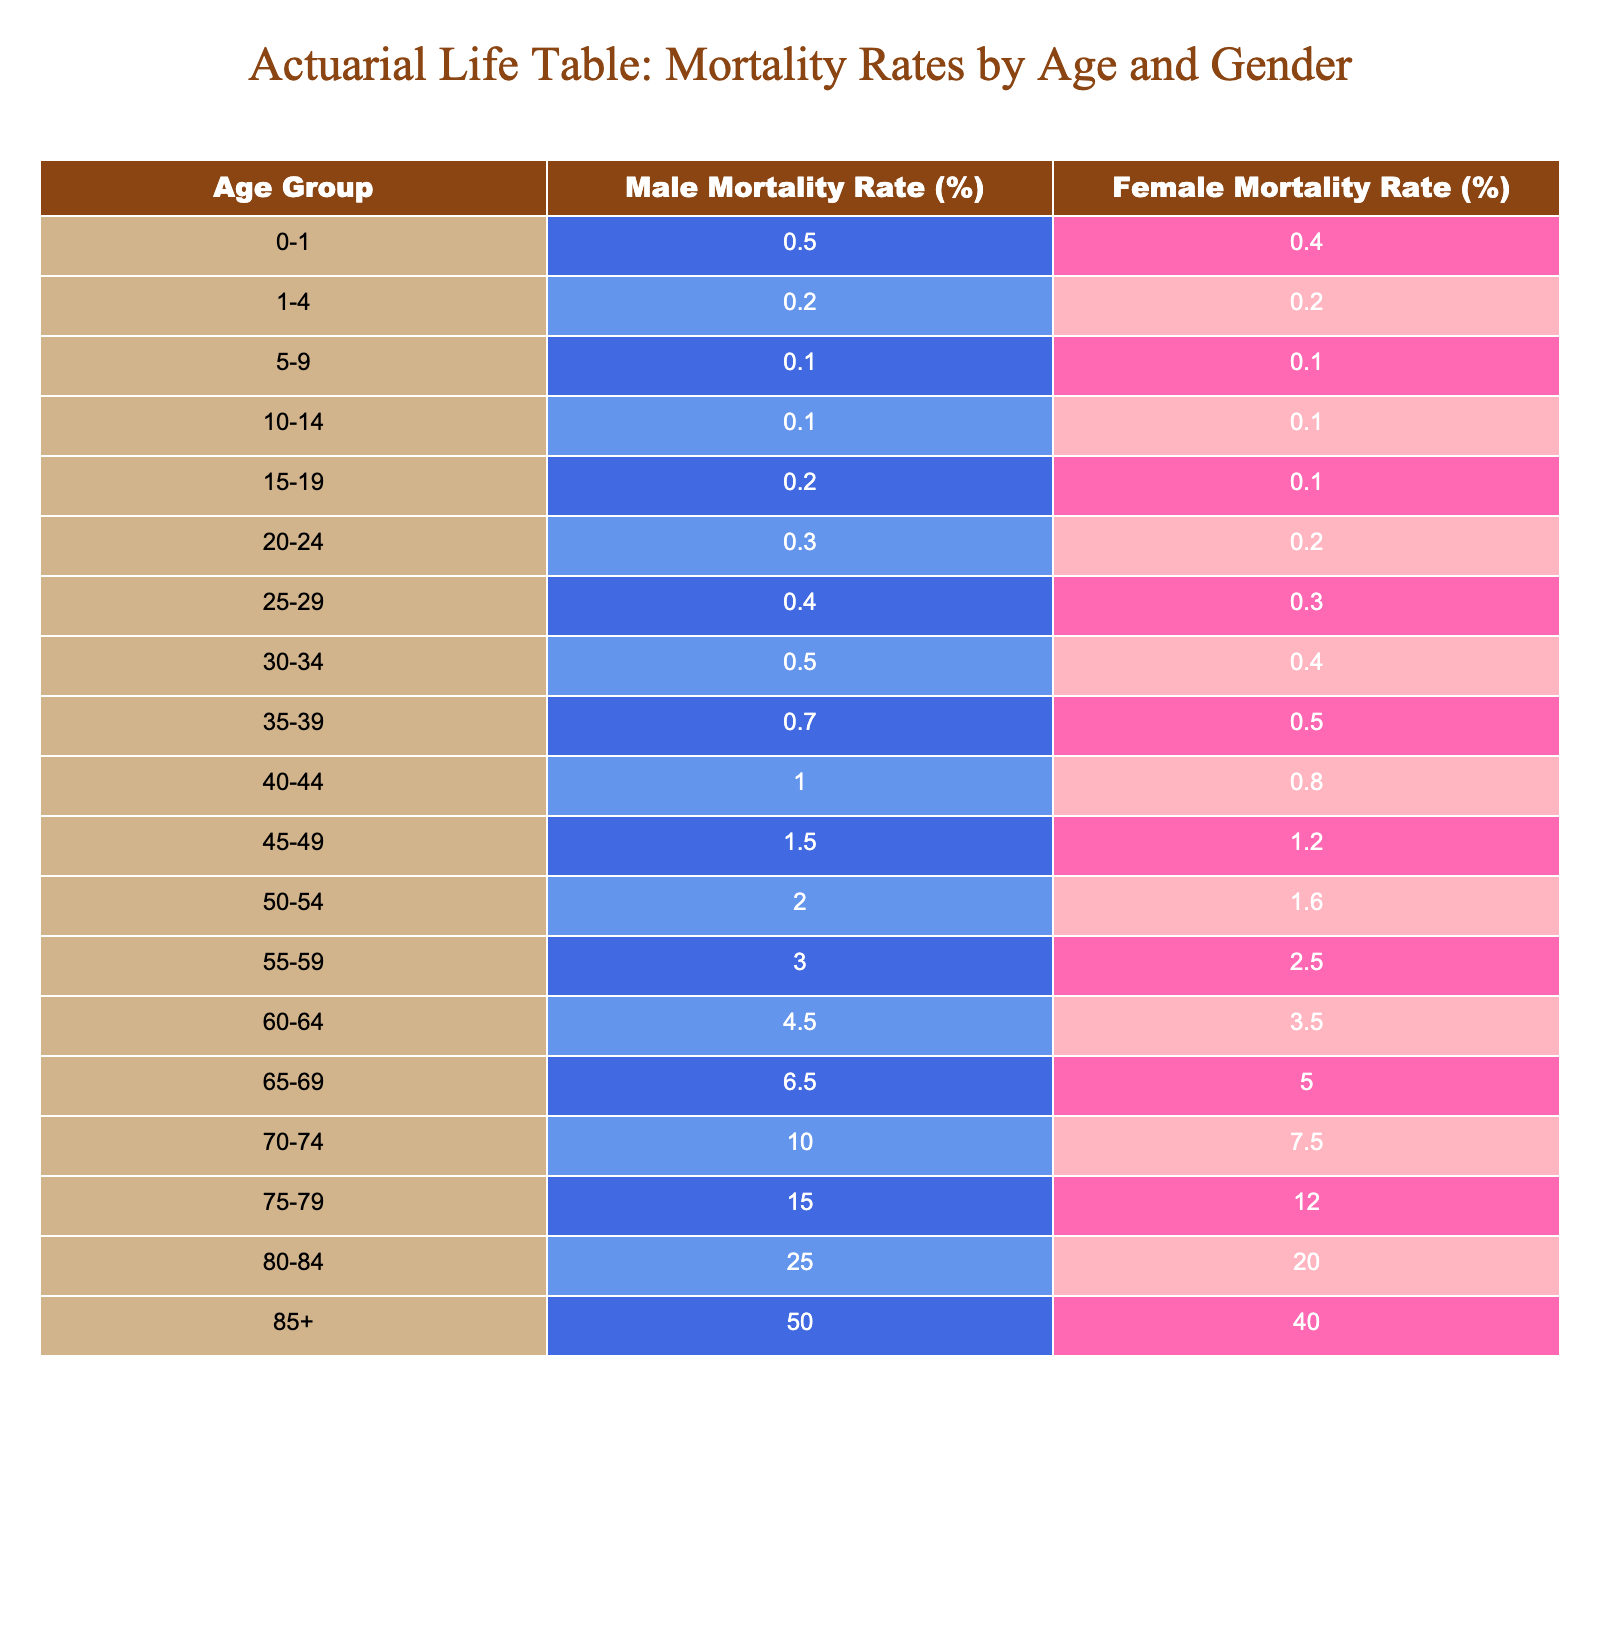What is the male mortality rate for the age group 60-64? The table shows that the male mortality rate for the age group 60-64 is 4.5%.
Answer: 4.5% What is the female mortality rate for the age group 25-29? From the table, the female mortality rate for the age group 25-29 is 0.3%.
Answer: 0.3% Which age group has the highest male mortality rate? Checking the table, the age group 85+ has the highest male mortality rate at 50.0%.
Answer: 85+ What is the difference in mortality rates between males and females for the age group 70-74? The male mortality rate is 10.0% and the female mortality rate is 7.5%. The difference is 10.0% - 7.5% = 2.5%.
Answer: 2.5% Is the female mortality rate for the age group 45-49 higher than that for the age group 50-54? The female mortality rate for 45-49 is 1.2% and for 50-54 is 1.6%. Since 1.2% is less than 1.6%, the statement is false.
Answer: No What is the average mortality rate for males across all age groups in the table? To find the average, sum up all the male mortality rates: (0.5 + 0.2 + 0.1 + 0.1 + 0.2 + 0.3 + 0.4 + 0.5 + 0.7 + 1.0 + 1.5 + 2.0 + 3.0 + 4.5 + 6.5 + 10.0 + 15.0 + 25.0 + 50.0) = 118.5%. There are 18 age groups, so the average is 118.5% / 18 ≈ 6.58%.
Answer: 6.58% What is the percentage for female mortality rates in the age group 55-59 compared to that for males in the same group? The female mortality rate for 55-59 is 2.5% and for males it is 3.0%. Thus, 2.5% is less than 3.0%, meaning females have lower mortality.
Answer: Yes Which gender has a higher mortality rate in the age group 80-84? In the age group 80-84, the male mortality rate is 25.0% while the female mortality rate is 20.0%. Therefore, males have a higher mortality rate.
Answer: Males 